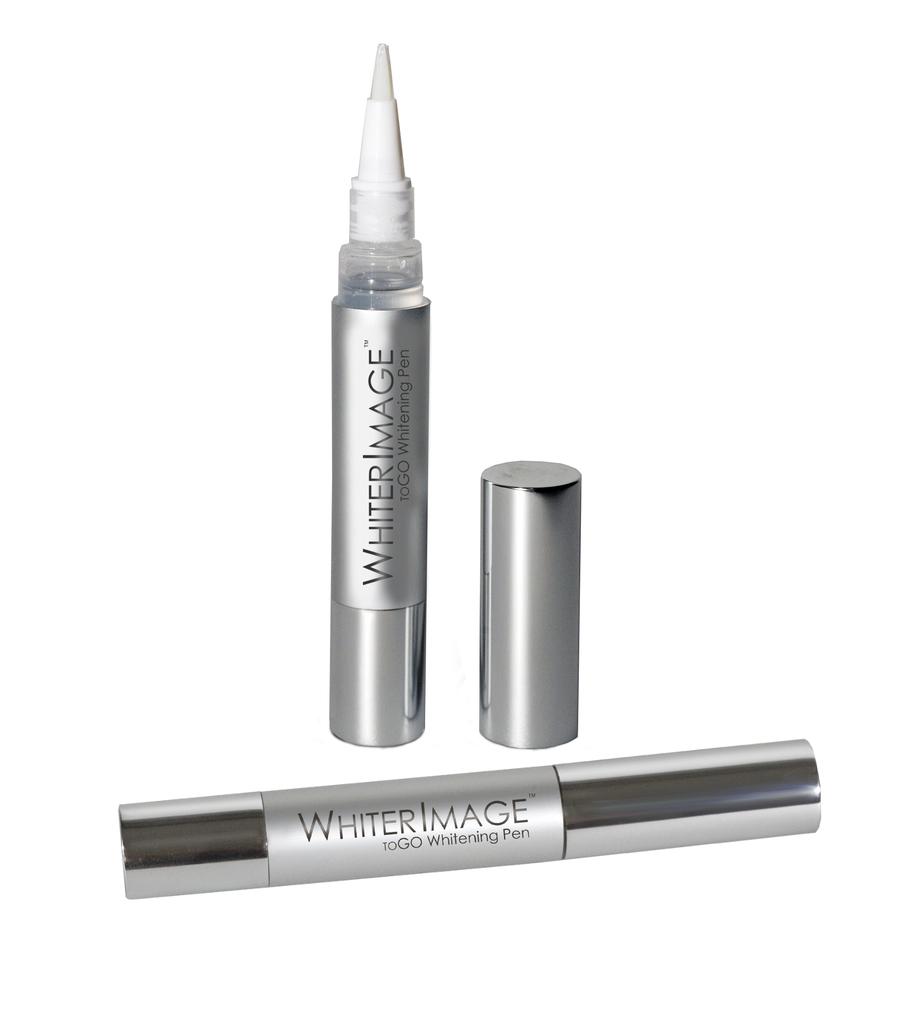What kind if pen is this?
Offer a terse response. Whiter image. What is the name of this item?
Provide a succinct answer. Whiter image. 